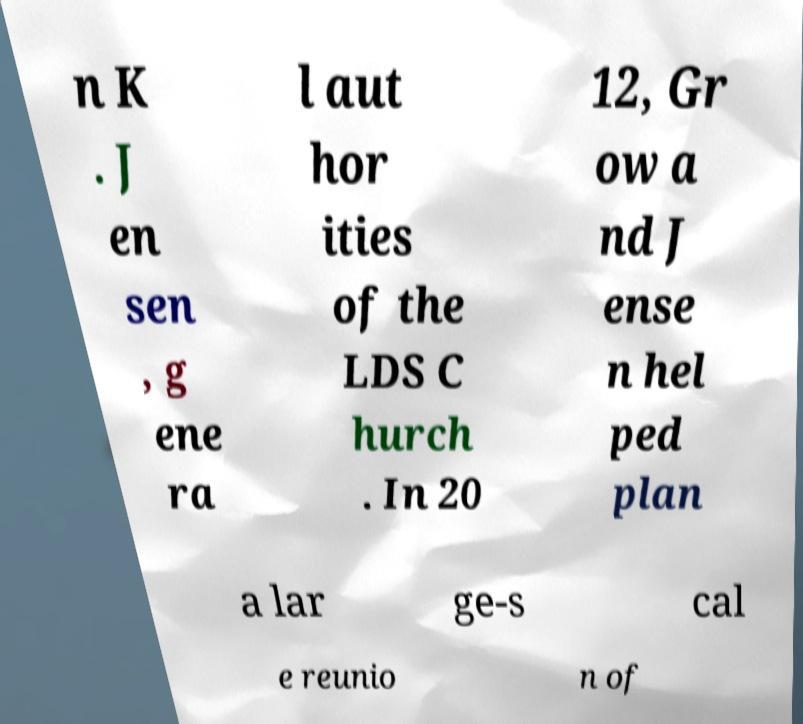There's text embedded in this image that I need extracted. Can you transcribe it verbatim? n K . J en sen , g ene ra l aut hor ities of the LDS C hurch . In 20 12, Gr ow a nd J ense n hel ped plan a lar ge-s cal e reunio n of 